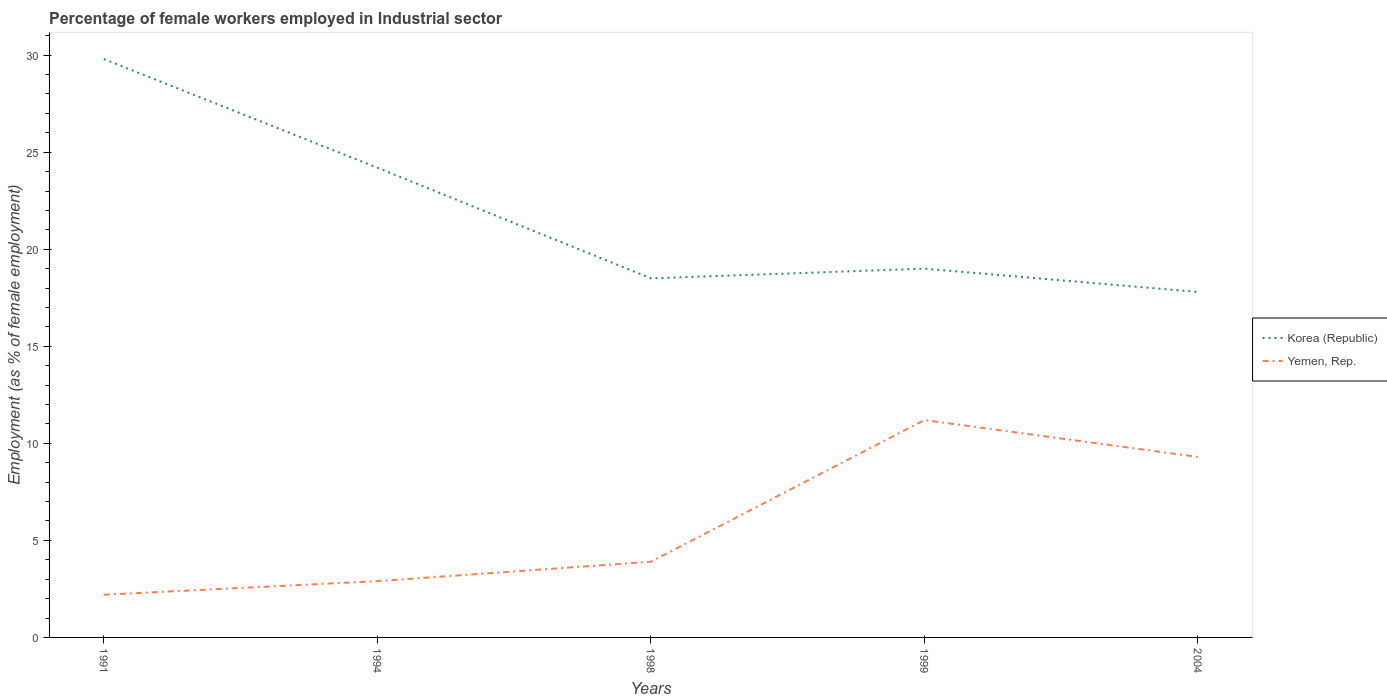How many different coloured lines are there?
Provide a short and direct response. 2. Is the number of lines equal to the number of legend labels?
Make the answer very short. Yes. Across all years, what is the maximum percentage of females employed in Industrial sector in Yemen, Rep.?
Keep it short and to the point. 2.2. In which year was the percentage of females employed in Industrial sector in Korea (Republic) maximum?
Offer a very short reply. 2004. What is the total percentage of females employed in Industrial sector in Yemen, Rep. in the graph?
Give a very brief answer. -1. What is the difference between the highest and the second highest percentage of females employed in Industrial sector in Yemen, Rep.?
Offer a terse response. 9. What is the difference between the highest and the lowest percentage of females employed in Industrial sector in Korea (Republic)?
Provide a succinct answer. 2. How many years are there in the graph?
Your answer should be compact. 5. What is the difference between two consecutive major ticks on the Y-axis?
Your answer should be very brief. 5. Are the values on the major ticks of Y-axis written in scientific E-notation?
Your answer should be very brief. No. Does the graph contain any zero values?
Offer a terse response. No. Where does the legend appear in the graph?
Provide a succinct answer. Center right. What is the title of the graph?
Offer a terse response. Percentage of female workers employed in Industrial sector. Does "Austria" appear as one of the legend labels in the graph?
Offer a very short reply. No. What is the label or title of the Y-axis?
Ensure brevity in your answer.  Employment (as % of female employment). What is the Employment (as % of female employment) in Korea (Republic) in 1991?
Offer a terse response. 29.8. What is the Employment (as % of female employment) of Yemen, Rep. in 1991?
Ensure brevity in your answer.  2.2. What is the Employment (as % of female employment) of Korea (Republic) in 1994?
Provide a short and direct response. 24.2. What is the Employment (as % of female employment) in Yemen, Rep. in 1994?
Offer a terse response. 2.9. What is the Employment (as % of female employment) of Yemen, Rep. in 1998?
Keep it short and to the point. 3.9. What is the Employment (as % of female employment) in Korea (Republic) in 1999?
Give a very brief answer. 19. What is the Employment (as % of female employment) of Yemen, Rep. in 1999?
Give a very brief answer. 11.2. What is the Employment (as % of female employment) in Korea (Republic) in 2004?
Provide a succinct answer. 17.8. What is the Employment (as % of female employment) in Yemen, Rep. in 2004?
Keep it short and to the point. 9.3. Across all years, what is the maximum Employment (as % of female employment) of Korea (Republic)?
Make the answer very short. 29.8. Across all years, what is the maximum Employment (as % of female employment) in Yemen, Rep.?
Give a very brief answer. 11.2. Across all years, what is the minimum Employment (as % of female employment) in Korea (Republic)?
Provide a short and direct response. 17.8. Across all years, what is the minimum Employment (as % of female employment) of Yemen, Rep.?
Provide a short and direct response. 2.2. What is the total Employment (as % of female employment) in Korea (Republic) in the graph?
Your answer should be compact. 109.3. What is the total Employment (as % of female employment) of Yemen, Rep. in the graph?
Ensure brevity in your answer.  29.5. What is the difference between the Employment (as % of female employment) of Yemen, Rep. in 1991 and that in 1999?
Offer a terse response. -9. What is the difference between the Employment (as % of female employment) of Korea (Republic) in 1994 and that in 2004?
Offer a very short reply. 6.4. What is the difference between the Employment (as % of female employment) of Yemen, Rep. in 1994 and that in 2004?
Offer a terse response. -6.4. What is the difference between the Employment (as % of female employment) in Korea (Republic) in 1998 and that in 2004?
Keep it short and to the point. 0.7. What is the difference between the Employment (as % of female employment) in Yemen, Rep. in 1998 and that in 2004?
Give a very brief answer. -5.4. What is the difference between the Employment (as % of female employment) in Korea (Republic) in 1991 and the Employment (as % of female employment) in Yemen, Rep. in 1994?
Provide a short and direct response. 26.9. What is the difference between the Employment (as % of female employment) of Korea (Republic) in 1991 and the Employment (as % of female employment) of Yemen, Rep. in 1998?
Your answer should be very brief. 25.9. What is the difference between the Employment (as % of female employment) of Korea (Republic) in 1994 and the Employment (as % of female employment) of Yemen, Rep. in 1998?
Ensure brevity in your answer.  20.3. What is the difference between the Employment (as % of female employment) in Korea (Republic) in 1998 and the Employment (as % of female employment) in Yemen, Rep. in 1999?
Give a very brief answer. 7.3. What is the difference between the Employment (as % of female employment) of Korea (Republic) in 1998 and the Employment (as % of female employment) of Yemen, Rep. in 2004?
Ensure brevity in your answer.  9.2. What is the difference between the Employment (as % of female employment) of Korea (Republic) in 1999 and the Employment (as % of female employment) of Yemen, Rep. in 2004?
Provide a succinct answer. 9.7. What is the average Employment (as % of female employment) in Korea (Republic) per year?
Your answer should be compact. 21.86. What is the average Employment (as % of female employment) of Yemen, Rep. per year?
Ensure brevity in your answer.  5.9. In the year 1991, what is the difference between the Employment (as % of female employment) in Korea (Republic) and Employment (as % of female employment) in Yemen, Rep.?
Give a very brief answer. 27.6. In the year 1994, what is the difference between the Employment (as % of female employment) in Korea (Republic) and Employment (as % of female employment) in Yemen, Rep.?
Give a very brief answer. 21.3. What is the ratio of the Employment (as % of female employment) in Korea (Republic) in 1991 to that in 1994?
Your answer should be compact. 1.23. What is the ratio of the Employment (as % of female employment) in Yemen, Rep. in 1991 to that in 1994?
Your response must be concise. 0.76. What is the ratio of the Employment (as % of female employment) of Korea (Republic) in 1991 to that in 1998?
Your response must be concise. 1.61. What is the ratio of the Employment (as % of female employment) of Yemen, Rep. in 1991 to that in 1998?
Provide a short and direct response. 0.56. What is the ratio of the Employment (as % of female employment) of Korea (Republic) in 1991 to that in 1999?
Your response must be concise. 1.57. What is the ratio of the Employment (as % of female employment) of Yemen, Rep. in 1991 to that in 1999?
Your answer should be very brief. 0.2. What is the ratio of the Employment (as % of female employment) of Korea (Republic) in 1991 to that in 2004?
Provide a succinct answer. 1.67. What is the ratio of the Employment (as % of female employment) of Yemen, Rep. in 1991 to that in 2004?
Your answer should be compact. 0.24. What is the ratio of the Employment (as % of female employment) of Korea (Republic) in 1994 to that in 1998?
Provide a short and direct response. 1.31. What is the ratio of the Employment (as % of female employment) in Yemen, Rep. in 1994 to that in 1998?
Make the answer very short. 0.74. What is the ratio of the Employment (as % of female employment) in Korea (Republic) in 1994 to that in 1999?
Your answer should be compact. 1.27. What is the ratio of the Employment (as % of female employment) in Yemen, Rep. in 1994 to that in 1999?
Ensure brevity in your answer.  0.26. What is the ratio of the Employment (as % of female employment) in Korea (Republic) in 1994 to that in 2004?
Provide a short and direct response. 1.36. What is the ratio of the Employment (as % of female employment) in Yemen, Rep. in 1994 to that in 2004?
Offer a very short reply. 0.31. What is the ratio of the Employment (as % of female employment) of Korea (Republic) in 1998 to that in 1999?
Your answer should be compact. 0.97. What is the ratio of the Employment (as % of female employment) of Yemen, Rep. in 1998 to that in 1999?
Make the answer very short. 0.35. What is the ratio of the Employment (as % of female employment) in Korea (Republic) in 1998 to that in 2004?
Your answer should be very brief. 1.04. What is the ratio of the Employment (as % of female employment) of Yemen, Rep. in 1998 to that in 2004?
Provide a succinct answer. 0.42. What is the ratio of the Employment (as % of female employment) in Korea (Republic) in 1999 to that in 2004?
Provide a succinct answer. 1.07. What is the ratio of the Employment (as % of female employment) in Yemen, Rep. in 1999 to that in 2004?
Your answer should be compact. 1.2. What is the difference between the highest and the second highest Employment (as % of female employment) in Korea (Republic)?
Offer a terse response. 5.6. What is the difference between the highest and the lowest Employment (as % of female employment) of Korea (Republic)?
Your answer should be compact. 12. 